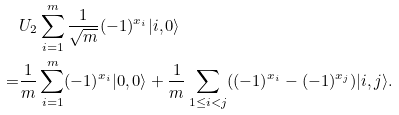Convert formula to latex. <formula><loc_0><loc_0><loc_500><loc_500>& U _ { 2 } \sum _ { i = 1 } ^ { m } \frac { 1 } { \sqrt { m } } ( - 1 ) ^ { x _ { i } } | i , 0 \rangle \\ = & \frac { 1 } { m } \sum _ { i = 1 } ^ { m } ( - 1 ) ^ { x _ { i } } | 0 , 0 \rangle + \frac { 1 } { m } \sum _ { 1 \leq i < j } ( ( - 1 ) ^ { x _ { i } } - ( - 1 ) ^ { x _ { j } } ) | i , j \rangle .</formula> 